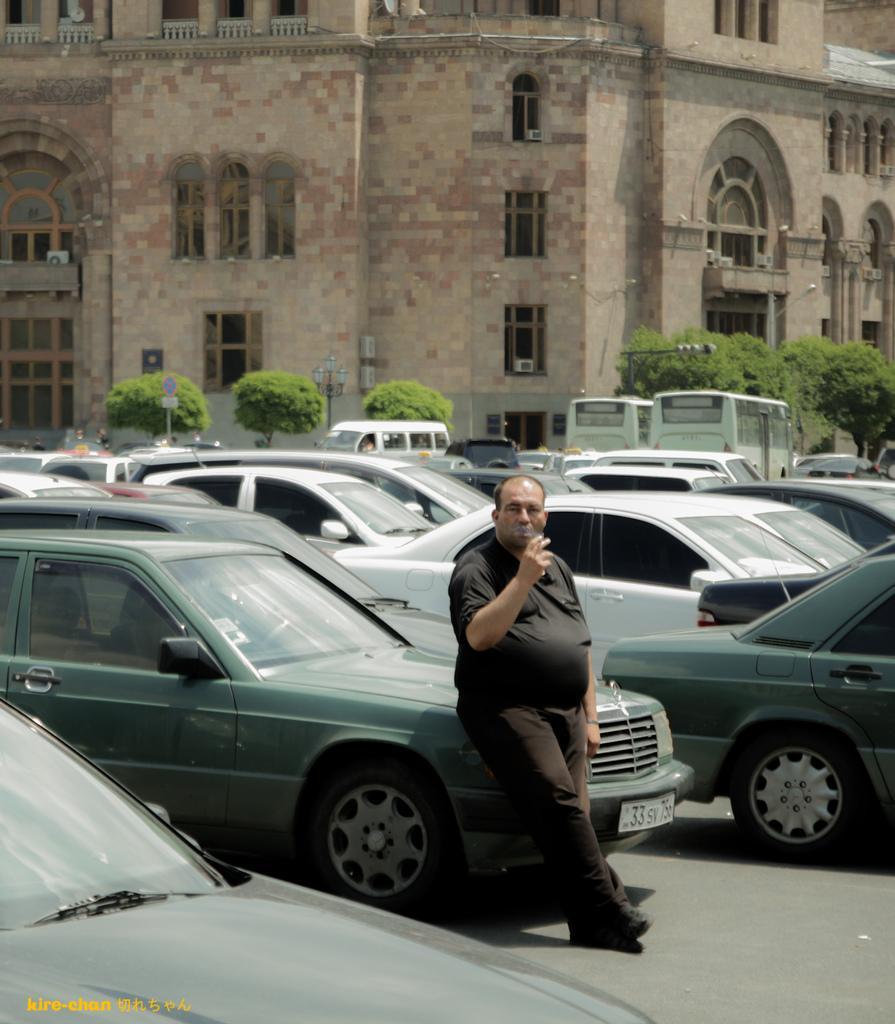In one or two sentences, can you explain what this image depicts? In this image we can see one Big Building. In front of that building so many trees are there. One sign board is there, one light is there. In front of the building one road is there So many vehicles are moving and signal board is there. In parking area so many cars are parked. In front of one car one person is standing and smoking. 